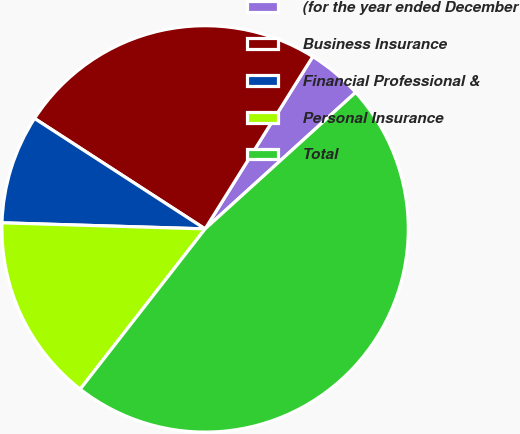<chart> <loc_0><loc_0><loc_500><loc_500><pie_chart><fcel>(for the year ended December<fcel>Business Insurance<fcel>Financial Professional &<fcel>Personal Insurance<fcel>Total<nl><fcel>4.39%<fcel>24.74%<fcel>8.67%<fcel>14.94%<fcel>47.26%<nl></chart> 